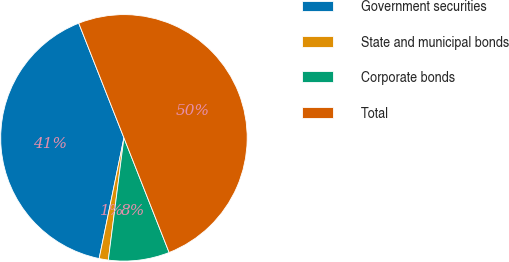Convert chart. <chart><loc_0><loc_0><loc_500><loc_500><pie_chart><fcel>Government securities<fcel>State and municipal bonds<fcel>Corporate bonds<fcel>Total<nl><fcel>40.8%<fcel>1.2%<fcel>8.0%<fcel>50.0%<nl></chart> 